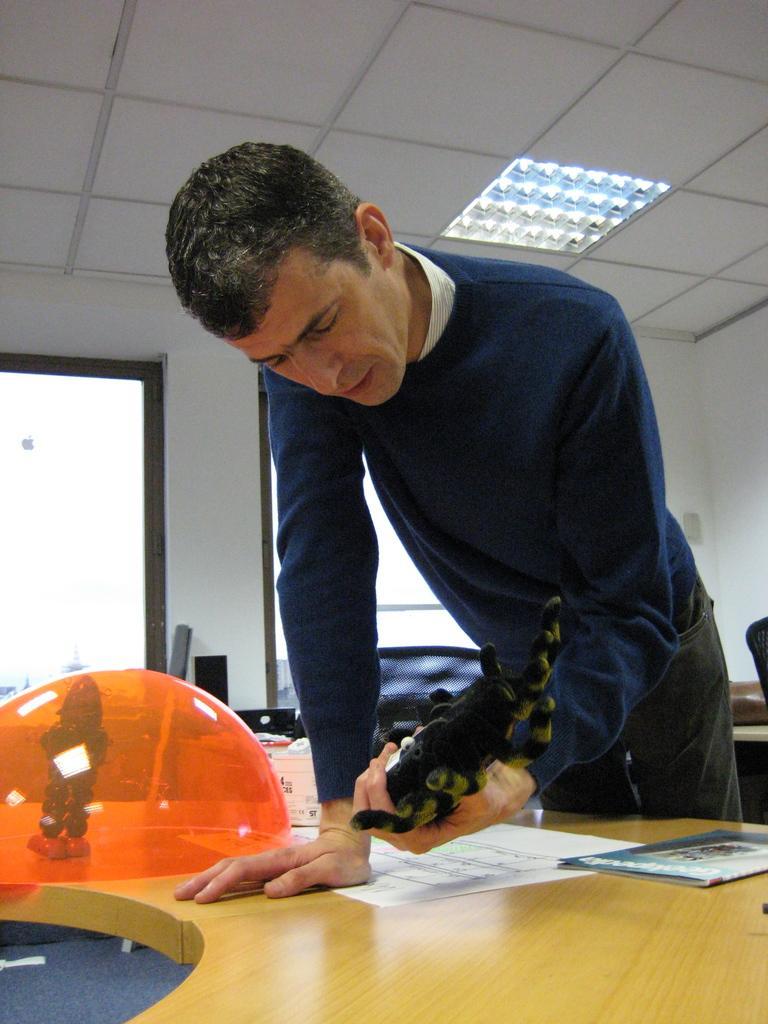How would you summarize this image in a sentence or two? Man standing,on table there are papers,toy and there are windows. 